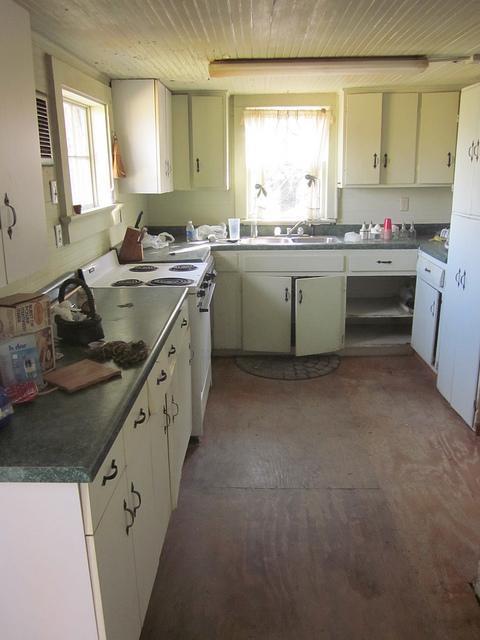What is the black and white object to the left of the window?
Answer the question by selecting the correct answer among the 4 following choices and explain your choice with a short sentence. The answer should be formatted with the following format: `Answer: choice
Rationale: rationale.`
Options: Vent, iron decoration, picture, pan. Answer: vent.
Rationale: There are slats in it to filter out air 